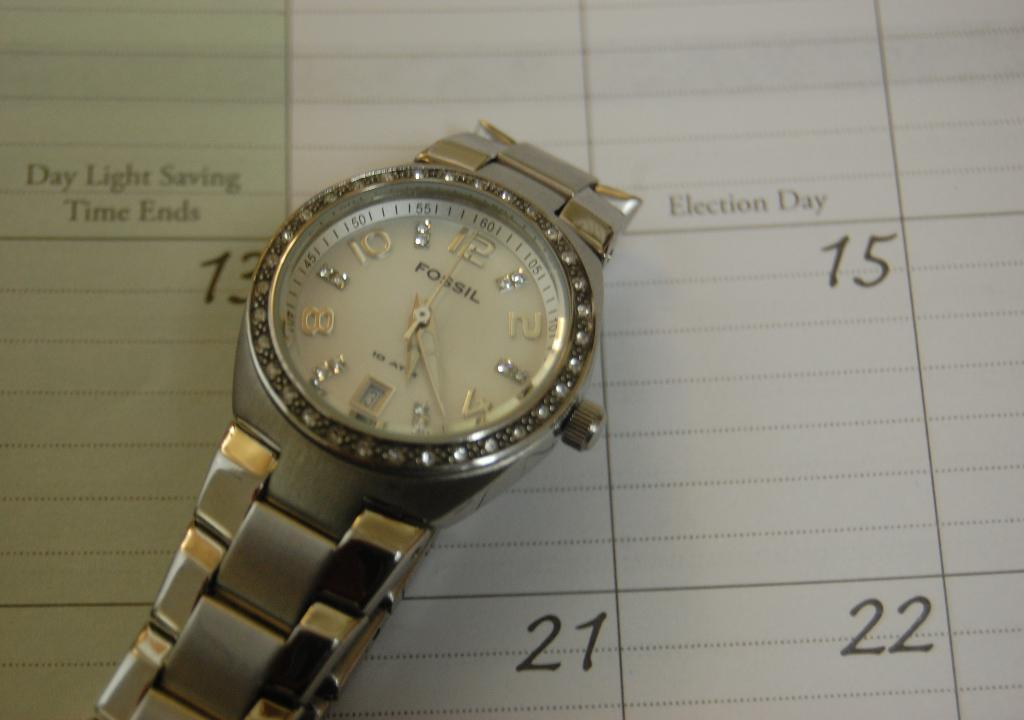<image>
Create a compact narrative representing the image presented. The watch sitting on top of a calendar is manufactured by "Fossil." 